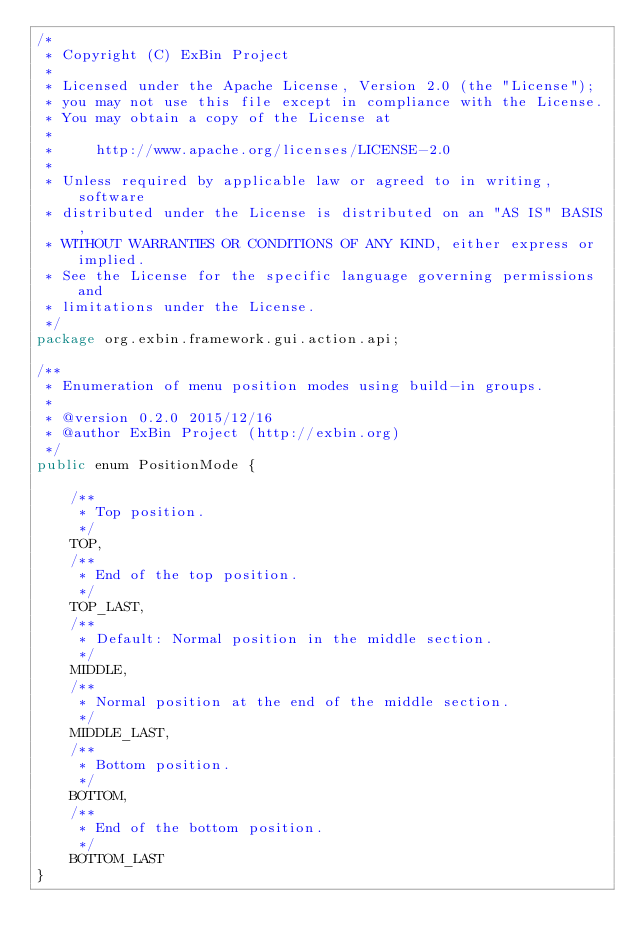<code> <loc_0><loc_0><loc_500><loc_500><_Java_>/*
 * Copyright (C) ExBin Project
 *
 * Licensed under the Apache License, Version 2.0 (the "License");
 * you may not use this file except in compliance with the License.
 * You may obtain a copy of the License at
 *
 *     http://www.apache.org/licenses/LICENSE-2.0
 *
 * Unless required by applicable law or agreed to in writing, software
 * distributed under the License is distributed on an "AS IS" BASIS,
 * WITHOUT WARRANTIES OR CONDITIONS OF ANY KIND, either express or implied.
 * See the License for the specific language governing permissions and
 * limitations under the License.
 */
package org.exbin.framework.gui.action.api;

/**
 * Enumeration of menu position modes using build-in groups.
 *
 * @version 0.2.0 2015/12/16
 * @author ExBin Project (http://exbin.org)
 */
public enum PositionMode {

    /**
     * Top position.
     */
    TOP,
    /**
     * End of the top position.
     */
    TOP_LAST,
    /**
     * Default: Normal position in the middle section.
     */
    MIDDLE,
    /**
     * Normal position at the end of the middle section.
     */
    MIDDLE_LAST,
    /**
     * Bottom position.
     */
    BOTTOM,
    /**
     * End of the bottom position.
     */
    BOTTOM_LAST
}
</code> 